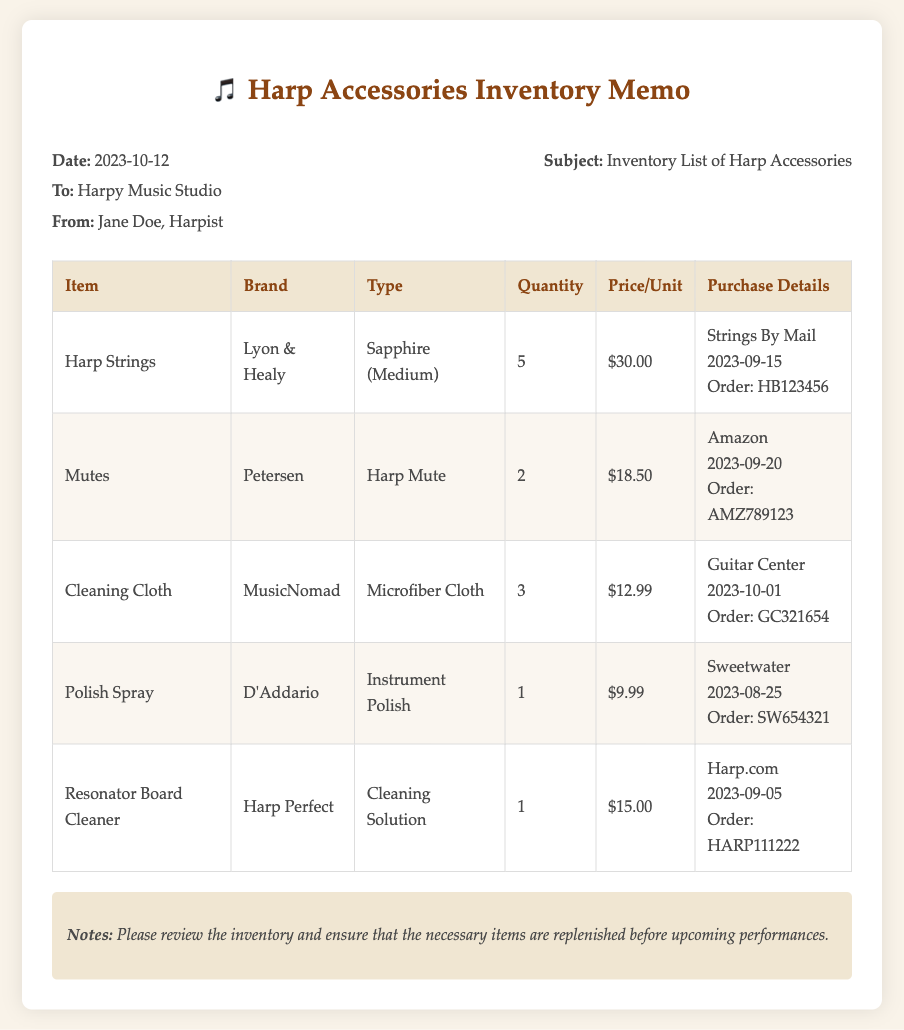What is the date of the memo? The date is mentioned in the memo under the details section, which states, "Date: 2023-10-12."
Answer: 2023-10-12 Who is the memo addressed to? The memo specifies that it is addressed to "Harpy Music Studio."
Answer: Harpy Music Studio What is the quantity of Harp Strings listed? The document indicates the quantity under the "Quantity" column in the table, which shows "5" for Harp Strings.
Answer: 5 How much does a Polish Spray cost? The price for Polish Spray is specified in the "Price/Unit" column of the table as "$9.99."
Answer: $9.99 What type of cleaning supply is the MusicNomad product? The "Type" column for MusicNomad specifies that the product is a "Microfiber Cloth."
Answer: Microfiber Cloth Which brand supplies the resonator board cleaner? The brand for the "Resonator Board Cleaner" is noted in the table as "Harp Perfect."
Answer: Harp Perfect What should be ensured before upcoming performances according to the notes? The notes section states to "ensure that the necessary items are replenished."
Answer: replenished How many mutes are in inventory? The quantity for mutes is included in the table, which states "2" under the "Quantity" column.
Answer: 2 What is the purchase date for the Cleaning Cloth? The purchase details in the table shows the date for Cleaning Cloth as "2023-10-01."
Answer: 2023-10-01 